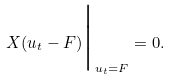<formula> <loc_0><loc_0><loc_500><loc_500>X ( u _ { t } - F ) \Big | _ { u _ { t } = F } = 0 .</formula> 